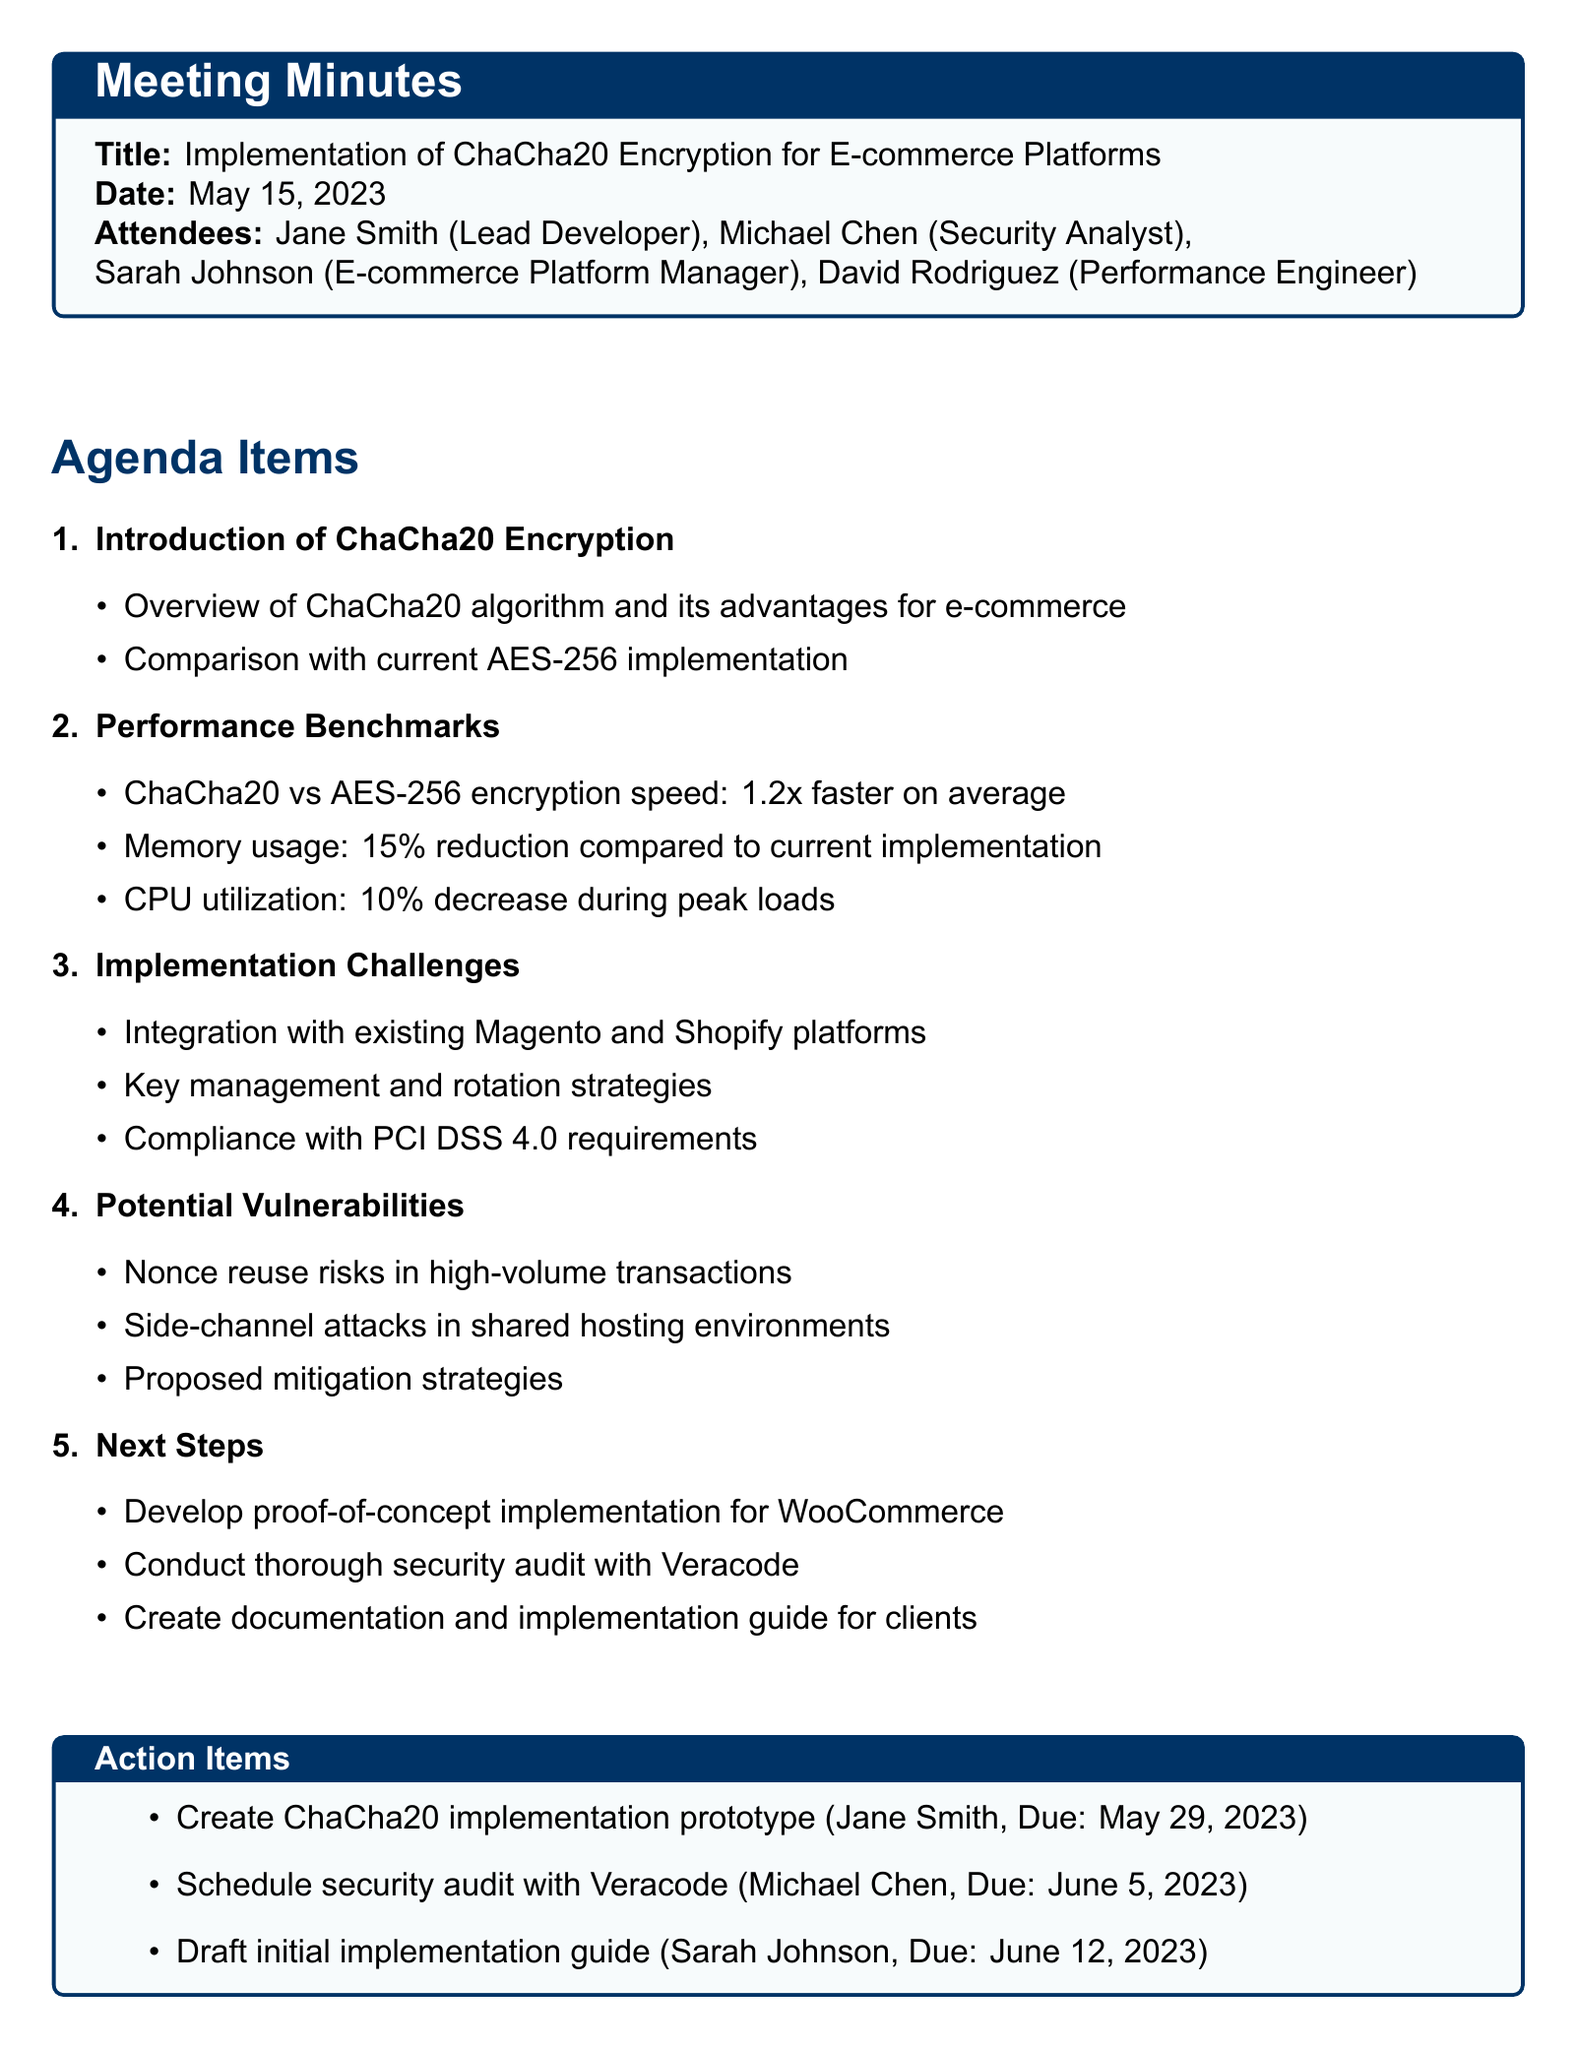what is the meeting title? The meeting title is explicitly stated at the beginning of the document.
Answer: Implementation of ChaCha20 Encryption for E-commerce Platforms who was the assignee for the implementation prototype? The action items section lists the tasks along with their assignees.
Answer: Jane Smith when is the due date for scheduling the security audit? The specific due date for the security audit assignment is mentioned in the action items.
Answer: June 5, 2023 what is one of the performance benchmarks for ChaCha20? The document lists performance benchmarks comparing ChaCha20 with AES-256.
Answer: 1.2x faster on average what are the proposed mitigation strategies? This information is found under the section discussing potential vulnerabilities but isn't detailed in the minutes.
Answer: Proposed mitigation strategies which platforms need integration for the new encryption? The challenges of implementation under agenda items specify the platforms involved.
Answer: Magento and Shopify what is the date of the meeting? The date of the meeting is clearly stated in the document.
Answer: May 15, 2023 what needs to be drafted by Sarah Johnson? The action items explicitly mention what each assignee is tasked with.
Answer: initial implementation guide how many attendees were present at the meeting? The number of attendees is specified in the attendee list.
Answer: Four 